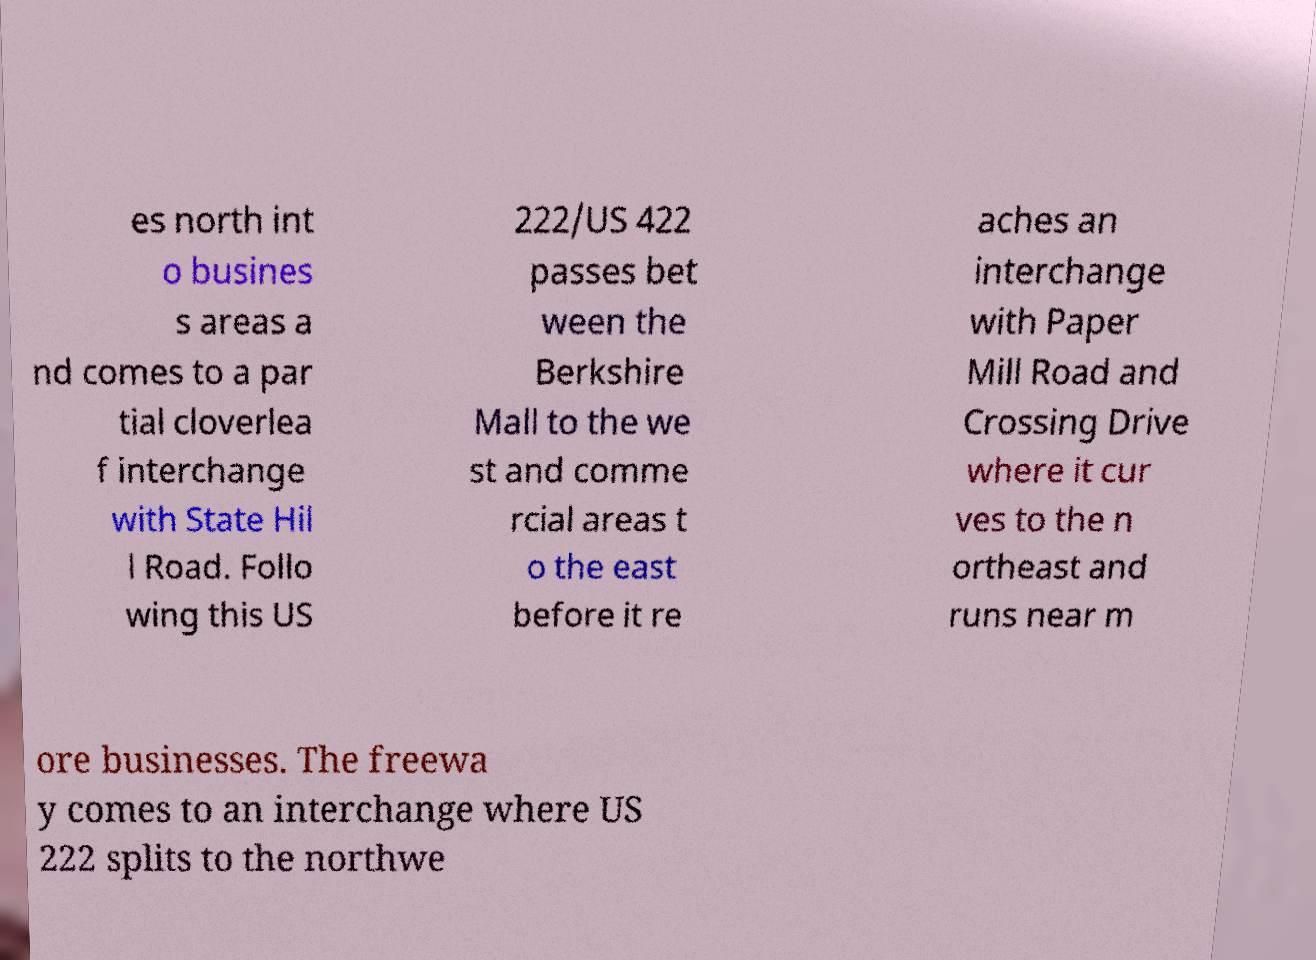What messages or text are displayed in this image? I need them in a readable, typed format. es north int o busines s areas a nd comes to a par tial cloverlea f interchange with State Hil l Road. Follo wing this US 222/US 422 passes bet ween the Berkshire Mall to the we st and comme rcial areas t o the east before it re aches an interchange with Paper Mill Road and Crossing Drive where it cur ves to the n ortheast and runs near m ore businesses. The freewa y comes to an interchange where US 222 splits to the northwe 